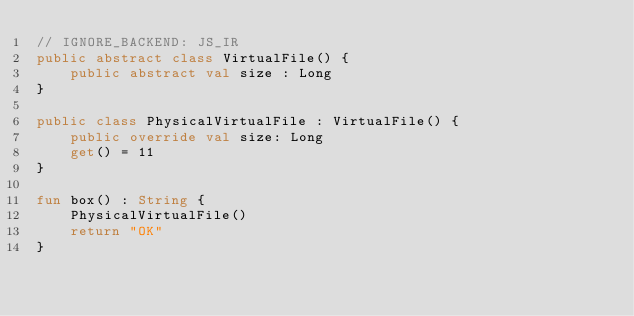<code> <loc_0><loc_0><loc_500><loc_500><_Kotlin_>// IGNORE_BACKEND: JS_IR
public abstract class VirtualFile() {
    public abstract val size : Long
}

public class PhysicalVirtualFile : VirtualFile() {
    public override val size: Long
    get() = 11
}

fun box() : String {
    PhysicalVirtualFile()
    return "OK"
}
</code> 